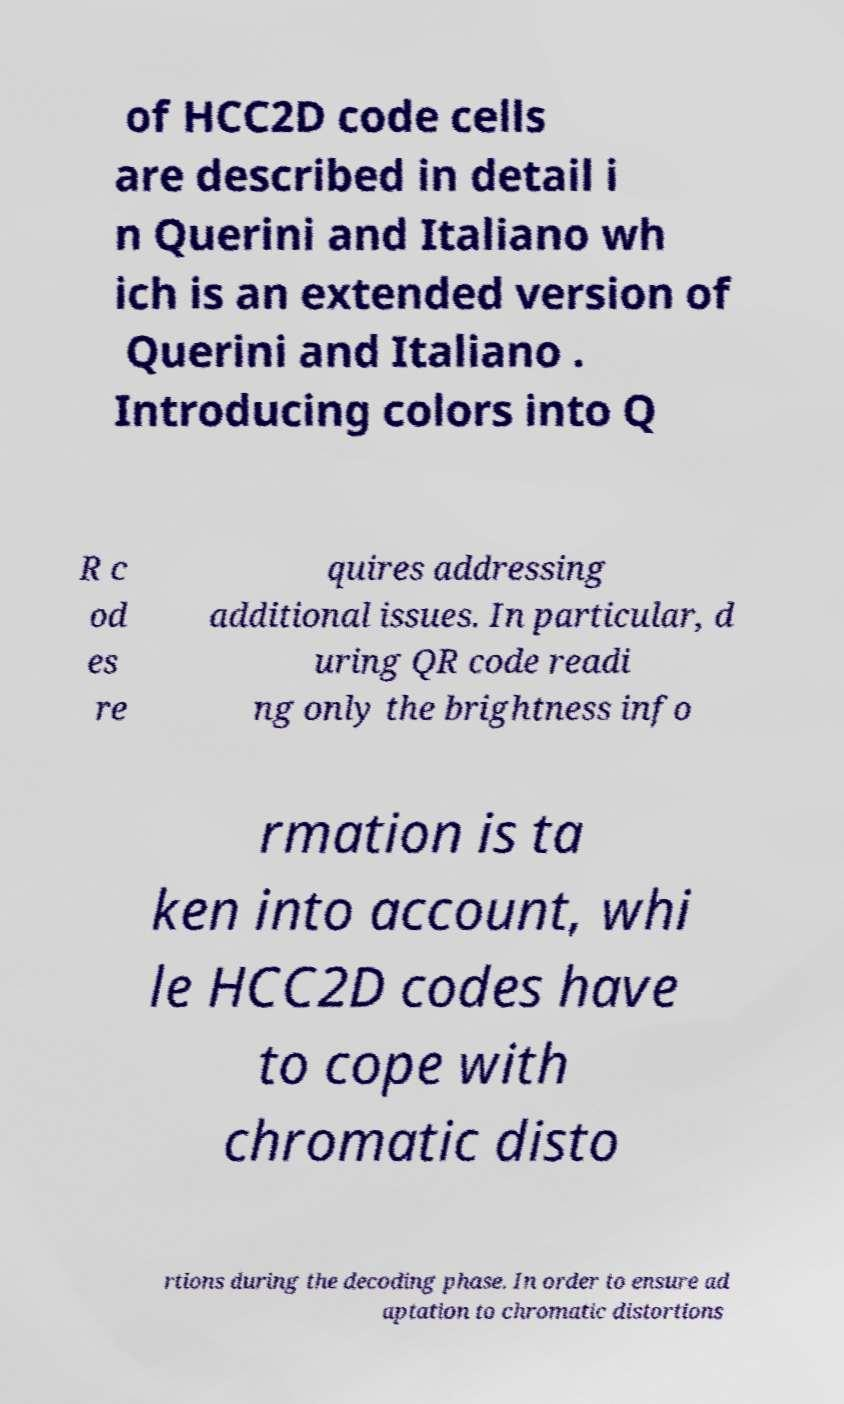Please read and relay the text visible in this image. What does it say? of HCC2D code cells are described in detail i n Querini and Italiano wh ich is an extended version of Querini and Italiano . Introducing colors into Q R c od es re quires addressing additional issues. In particular, d uring QR code readi ng only the brightness info rmation is ta ken into account, whi le HCC2D codes have to cope with chromatic disto rtions during the decoding phase. In order to ensure ad aptation to chromatic distortions 